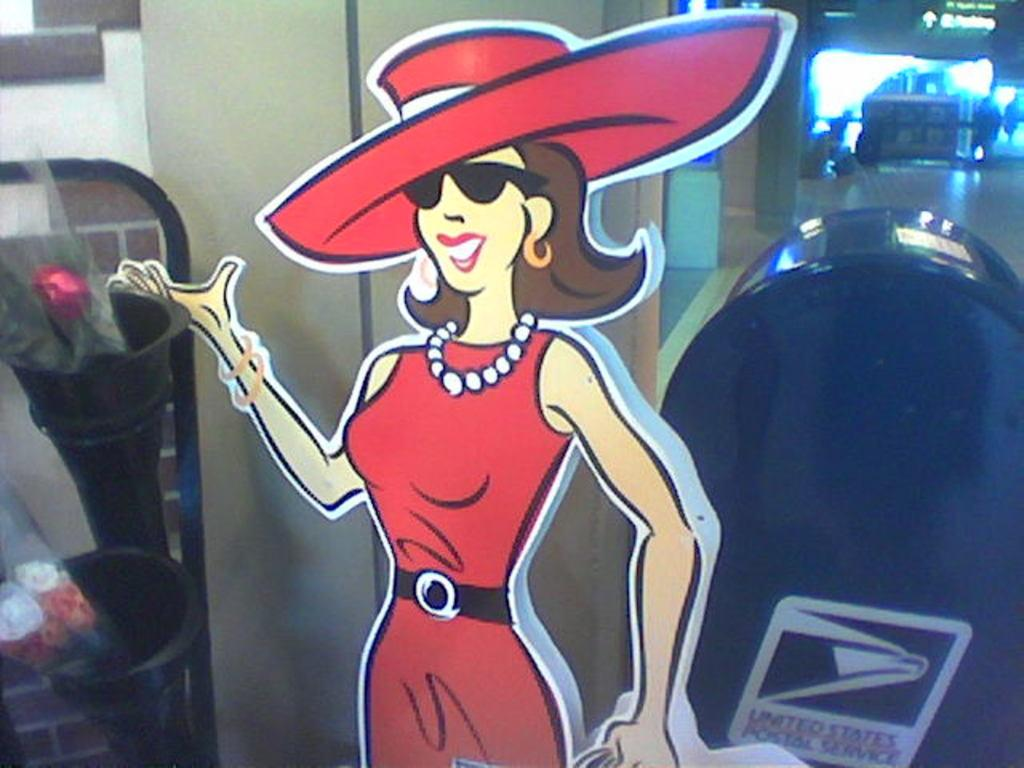Provide a one-sentence caption for the provided image. a cut out of a woman dressed in all red in front of a mail box. 